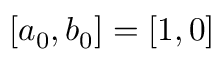<formula> <loc_0><loc_0><loc_500><loc_500>[ a _ { 0 } , b _ { 0 } ] = [ 1 , 0 ]</formula> 